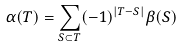<formula> <loc_0><loc_0><loc_500><loc_500>\alpha ( T ) = \sum _ { S \subset T } ( - 1 ) ^ { | T - S | } \beta ( S )</formula> 